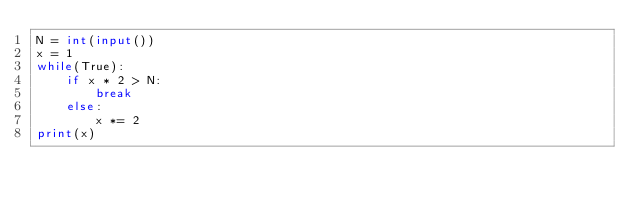Convert code to text. <code><loc_0><loc_0><loc_500><loc_500><_Python_>N = int(input())
x = 1
while(True):
    if x * 2 > N:
        break
    else:
        x *= 2
print(x)
</code> 